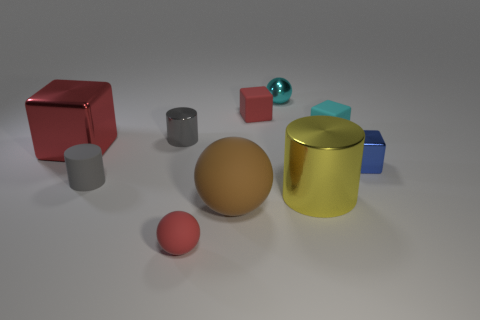What is the size of the red thing on the left side of the metal cylinder that is on the left side of the cyan metal thing? The red object appears to be a small cube, roughly smaller than the size of a standard die, when compared to the scale of objects surrounding it. 